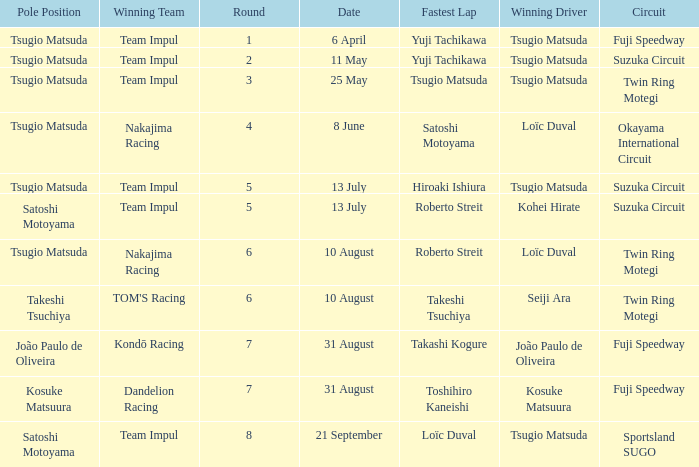Give me the full table as a dictionary. {'header': ['Pole Position', 'Winning Team', 'Round', 'Date', 'Fastest Lap', 'Winning Driver', 'Circuit'], 'rows': [['Tsugio Matsuda', 'Team Impul', '1', '6 April', 'Yuji Tachikawa', 'Tsugio Matsuda', 'Fuji Speedway'], ['Tsugio Matsuda', 'Team Impul', '2', '11 May', 'Yuji Tachikawa', 'Tsugio Matsuda', 'Suzuka Circuit'], ['Tsugio Matsuda', 'Team Impul', '3', '25 May', 'Tsugio Matsuda', 'Tsugio Matsuda', 'Twin Ring Motegi'], ['Tsugio Matsuda', 'Nakajima Racing', '4', '8 June', 'Satoshi Motoyama', 'Loïc Duval', 'Okayama International Circuit'], ['Tsugio Matsuda', 'Team Impul', '5', '13 July', 'Hiroaki Ishiura', 'Tsugio Matsuda', 'Suzuka Circuit'], ['Satoshi Motoyama', 'Team Impul', '5', '13 July', 'Roberto Streit', 'Kohei Hirate', 'Suzuka Circuit'], ['Tsugio Matsuda', 'Nakajima Racing', '6', '10 August', 'Roberto Streit', 'Loïc Duval', 'Twin Ring Motegi'], ['Takeshi Tsuchiya', "TOM'S Racing", '6', '10 August', 'Takeshi Tsuchiya', 'Seiji Ara', 'Twin Ring Motegi'], ['João Paulo de Oliveira', 'Kondō Racing', '7', '31 August', 'Takashi Kogure', 'João Paulo de Oliveira', 'Fuji Speedway'], ['Kosuke Matsuura', 'Dandelion Racing', '7', '31 August', 'Toshihiro Kaneishi', 'Kosuke Matsuura', 'Fuji Speedway'], ['Satoshi Motoyama', 'Team Impul', '8', '21 September', 'Loïc Duval', 'Tsugio Matsuda', 'Sportsland SUGO']]} What is the fastest lap for Seiji Ara? Takeshi Tsuchiya. 